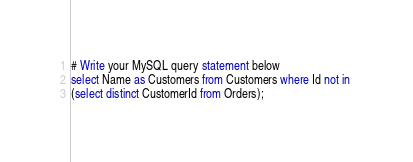Convert code to text. <code><loc_0><loc_0><loc_500><loc_500><_SQL_># Write your MySQL query statement below
select Name as Customers from Customers where Id not in 
(select distinct CustomerId from Orders);
</code> 